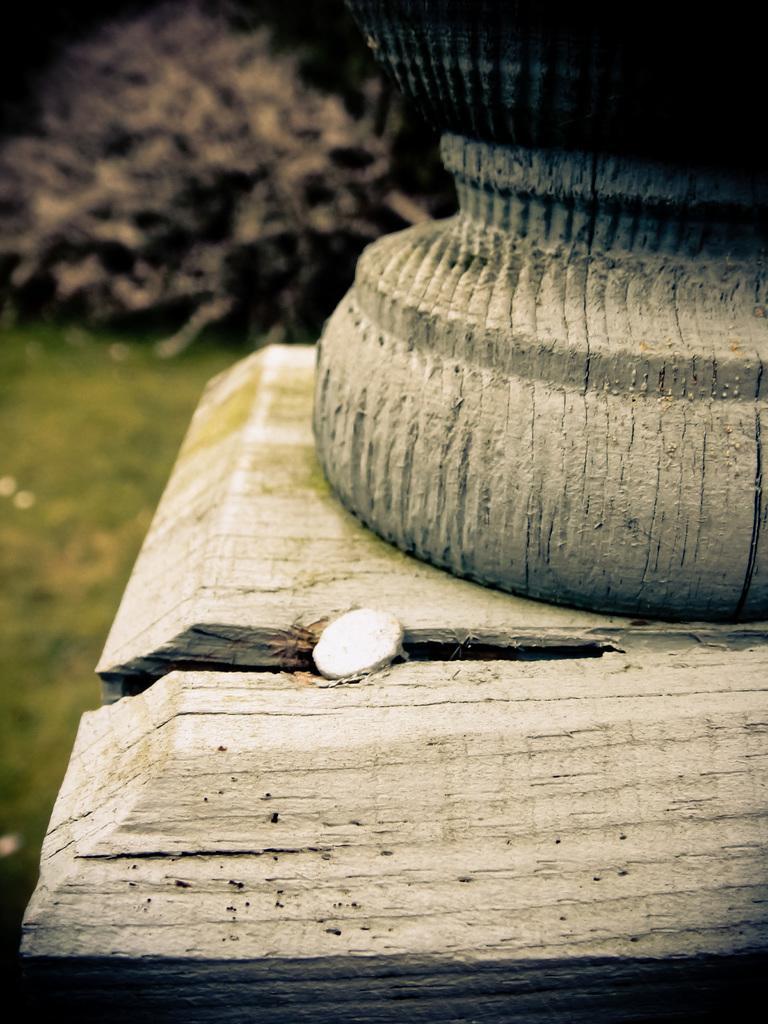Can you describe this image briefly? In the foreground of the picture we can see wooden objects. In the background there is greenery, it is not clear. 